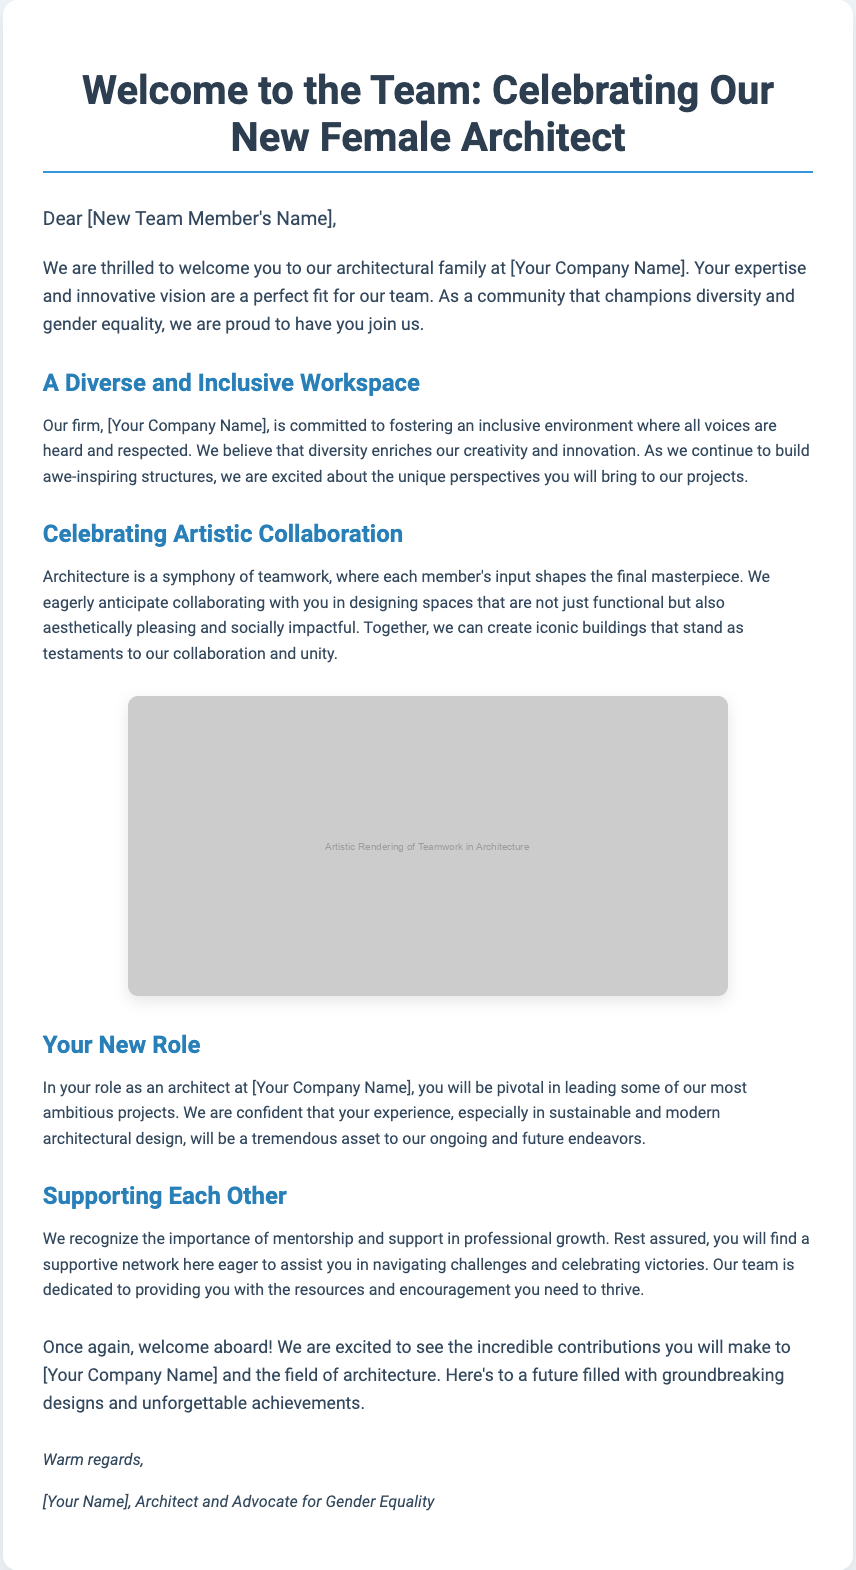What is the title of the card? The title of the card is explicitly stated at the top of the document, indicating its purpose.
Answer: Welcome to the Team: Celebrating Our New Female Architect What is the color of the text in the greeting section? The specific color used for the greeting text is mentioned in the styling section of the document.
Answer: #34495e Who is the intended recipient of the card? The card directly addresses the new team member by name, implying a personalized message.
Answer: [New Team Member's Name] What type of environment does the firm promote? The document describes the firm’s commitment to diversity and inclusiveness in a specific manner.
Answer: Inclusive What unique perspective does the new architect bring? The document indicates that new perspectives contribute to the firm's creative outputs.
Answer: Unique perspectives What role will the new architect play at the firm? The document specifies the level of responsibility the new architect will have in the projects.
Answer: Leading projects What does the firm prioritize in mentorship? According to the text, mentorship is highlighted as vital for professional development within the team.
Answer: Support How does the document describe the architectural collaboration? The text uses metaphorical language to describe the nature of teamwork in architecture.
Answer: A symphony What visual representation is included in the card? The card includes an image that reflects the theme of teamwork in architecture.
Answer: Artistic Rendering of Teamwork in Architecture 